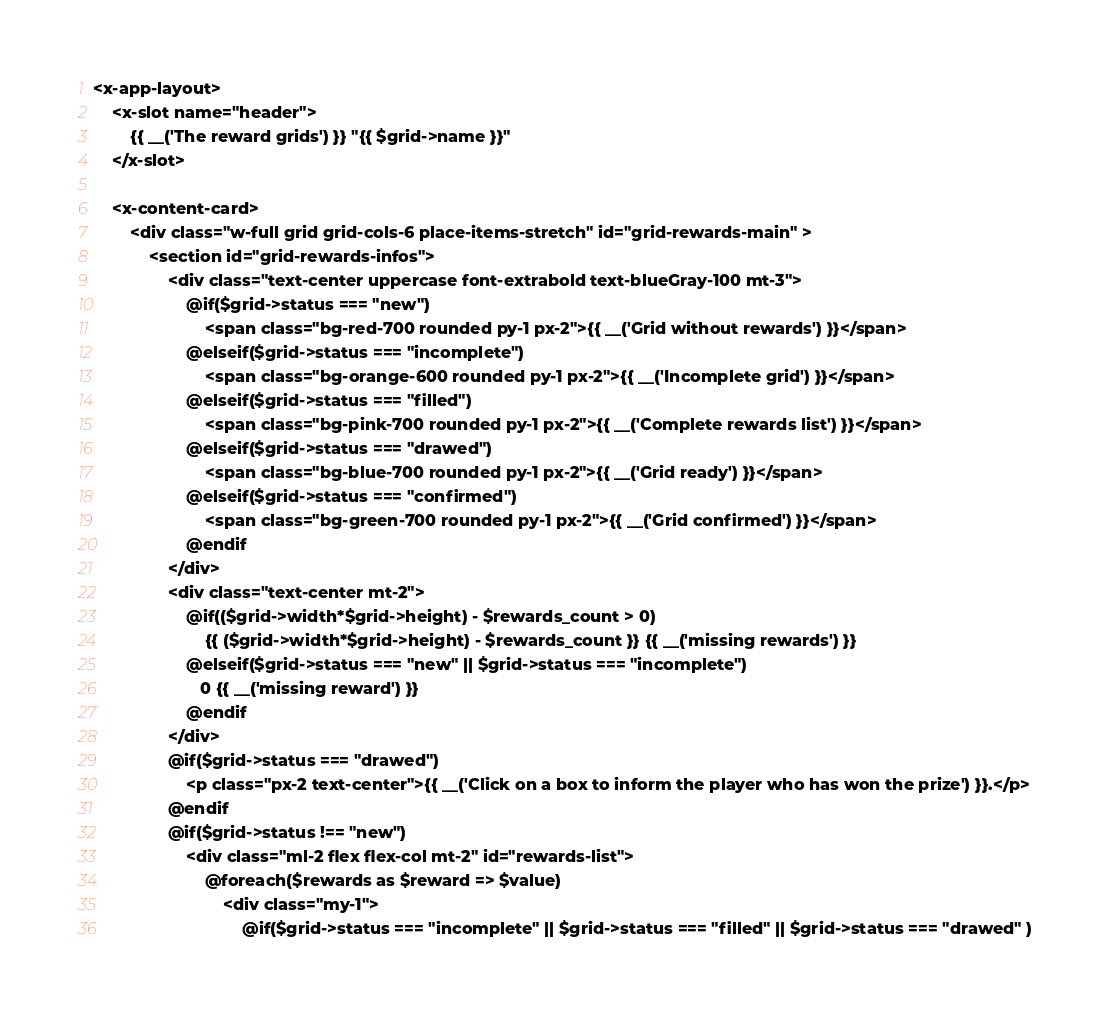<code> <loc_0><loc_0><loc_500><loc_500><_PHP_><x-app-layout>
    <x-slot name="header">
        {{ __('The reward grids') }} "{{ $grid->name }}"
    </x-slot>

    <x-content-card>
        <div class="w-full grid grid-cols-6 place-items-stretch" id="grid-rewards-main" >
            <section id="grid-rewards-infos">
                <div class="text-center uppercase font-extrabold text-blueGray-100 mt-3">
                    @if($grid->status === "new")
                        <span class="bg-red-700 rounded py-1 px-2">{{ __('Grid without rewards') }}</span>
                    @elseif($grid->status === "incomplete")
                        <span class="bg-orange-600 rounded py-1 px-2">{{ __('Incomplete grid') }}</span>
                    @elseif($grid->status === "filled")
                        <span class="bg-pink-700 rounded py-1 px-2">{{ __('Complete rewards list') }}</span>
                    @elseif($grid->status === "drawed")
                        <span class="bg-blue-700 rounded py-1 px-2">{{ __('Grid ready') }}</span>
                    @elseif($grid->status === "confirmed")
                        <span class="bg-green-700 rounded py-1 px-2">{{ __('Grid confirmed') }}</span>
                    @endif
                </div>
                <div class="text-center mt-2">
                    @if(($grid->width*$grid->height) - $rewards_count > 0)
                        {{ ($grid->width*$grid->height) - $rewards_count }} {{ __('missing rewards') }}
                    @elseif($grid->status === "new" || $grid->status === "incomplete")
                       0 {{ __('missing reward') }}
                    @endif
                </div>
                @if($grid->status === "drawed")
                    <p class="px-2 text-center">{{ __('Click on a box to inform the player who has won the prize') }}.</p>
                @endif
                @if($grid->status !== "new")
                    <div class="ml-2 flex flex-col mt-2" id="rewards-list">
                        @foreach($rewards as $reward => $value)
                            <div class="my-1">
                                @if($grid->status === "incomplete" || $grid->status === "filled" || $grid->status === "drawed" )</code> 